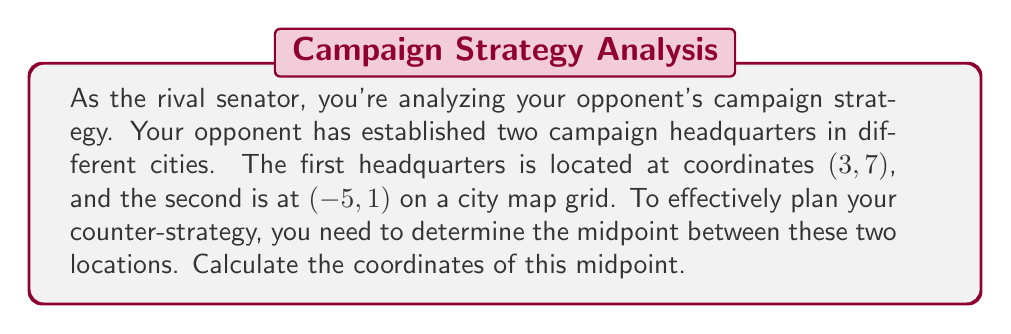What is the answer to this math problem? To find the midpoint between two points on a coordinate grid, we use the midpoint formula:

$$\text{Midpoint} = \left(\frac{x_1 + x_2}{2}, \frac{y_1 + y_2}{2}\right)$$

Where $(x_1, y_1)$ are the coordinates of the first point and $(x_2, y_2)$ are the coordinates of the second point.

Given:
- First headquarters: $(3, 7)$
- Second headquarters: $(-5, 1)$

Let's substitute these values into the midpoint formula:

$$\text{Midpoint} = \left(\frac{3 + (-5)}{2}, \frac{7 + 1}{2}\right)$$

Now, let's solve each component:

For the x-coordinate:
$$\frac{3 + (-5)}{2} = \frac{-2}{2} = -1$$

For the y-coordinate:
$$\frac{7 + 1}{2} = \frac{8}{2} = 4$$

Therefore, the midpoint coordinates are $(-1, 4)$.

[asy]
unitsize(1cm);
grid(-6,-1,4,8);
dot((3,7),red);
dot((-5,1),red);
dot((-1,4),blue);
label("(3, 7)", (3,7), NE, red);
label("(-5, 1)", (-5,1), SW, red);
label("(-1, 4)", (-1,4), SE, blue);
draw((3,7)--(-5,1), dashed);
[/asy]
Answer: The midpoint between the two campaign headquarters is located at $(-1, 4)$. 